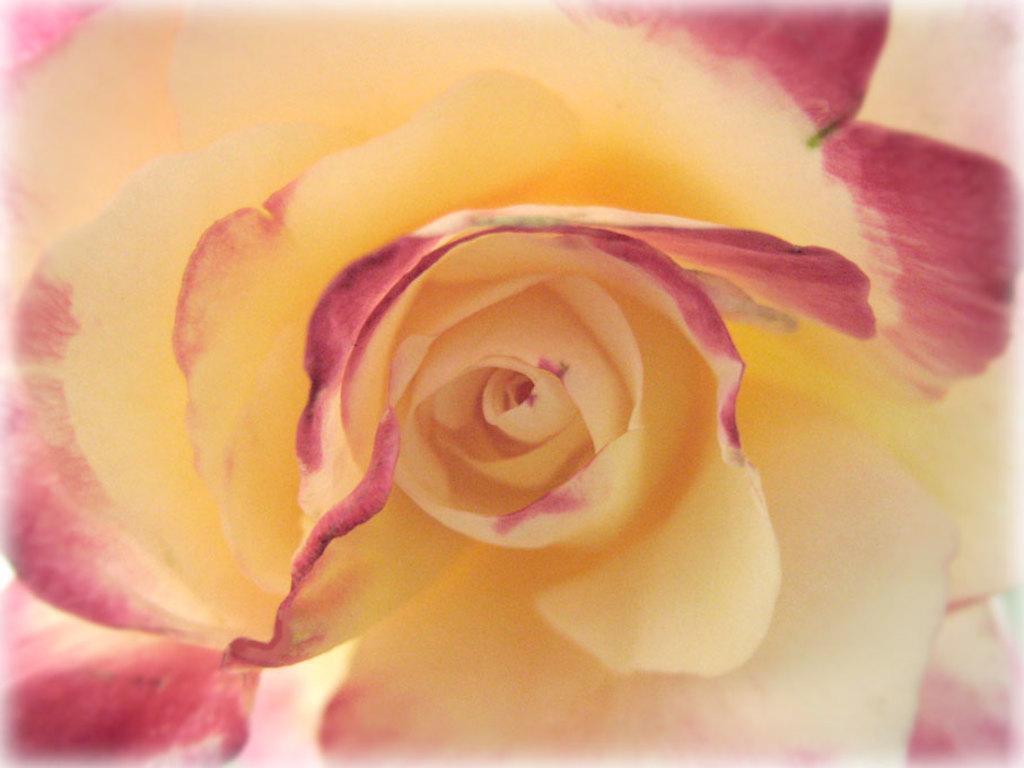Could you give a brief overview of what you see in this image? In this image I can see a yellow color flower. At the corner of this petals I can see pink color. 